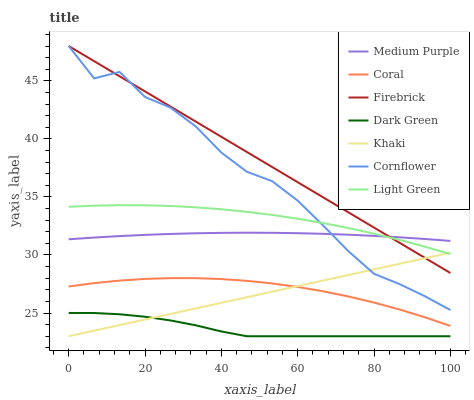Does Dark Green have the minimum area under the curve?
Answer yes or no. Yes. Does Khaki have the minimum area under the curve?
Answer yes or no. No. Does Khaki have the maximum area under the curve?
Answer yes or no. No. Is Cornflower the roughest?
Answer yes or no. Yes. Is Coral the smoothest?
Answer yes or no. No. Is Coral the roughest?
Answer yes or no. No. Does Coral have the lowest value?
Answer yes or no. No. Does Khaki have the highest value?
Answer yes or no. No. Is Dark Green less than Firebrick?
Answer yes or no. Yes. Is Medium Purple greater than Dark Green?
Answer yes or no. Yes. Does Dark Green intersect Firebrick?
Answer yes or no. No. 